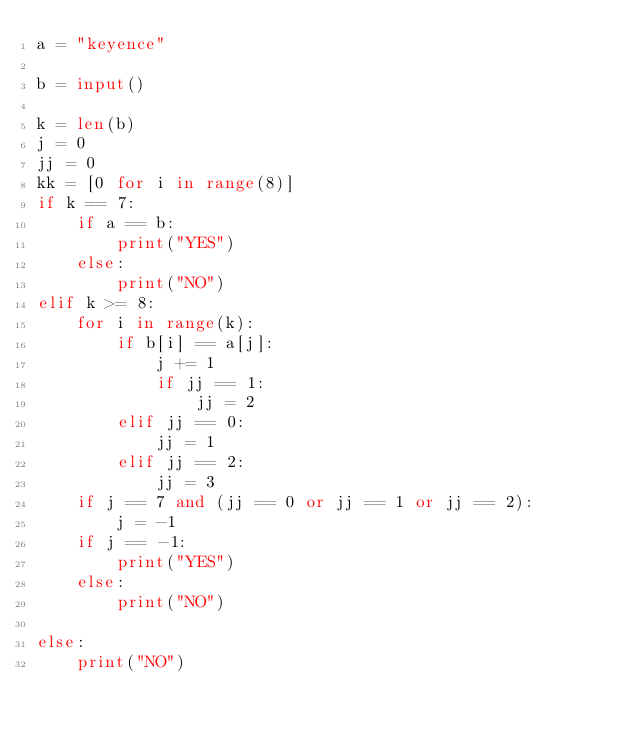<code> <loc_0><loc_0><loc_500><loc_500><_Python_>a = "keyence"

b = input()

k = len(b)
j = 0
jj = 0
kk = [0 for i in range(8)]
if k == 7:
	if a == b:
		print("YES")
	else:
		print("NO")
elif k >= 8:
	for i in range(k):
		if b[i] == a[j]:
			j += 1
			if jj == 1:
				jj = 2
		elif jj == 0:
			jj = 1
		elif jj == 2:
			jj = 3
	if j == 7 and (jj == 0 or jj == 1 or jj == 2):
		j = -1
	if j == -1:
		print("YES")
	else:
		print("NO")

else:
	print("NO")
</code> 